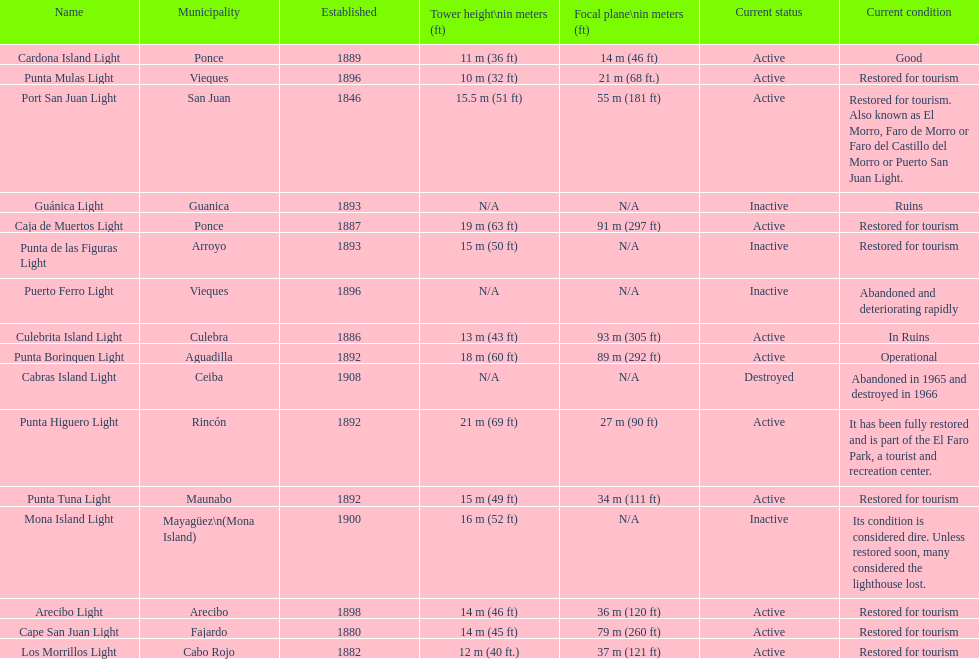Number of lighthouses that begin with the letter p 7. 